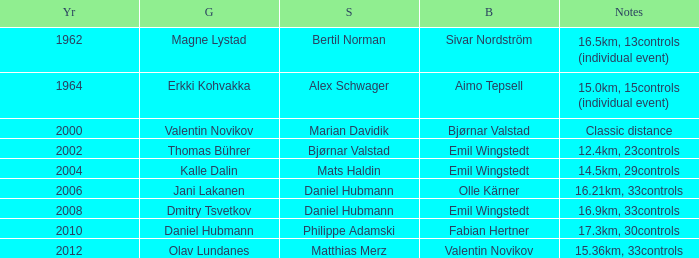WHAT IS THE SILVER WITH A YEAR OF 1962? Bertil Norman. 